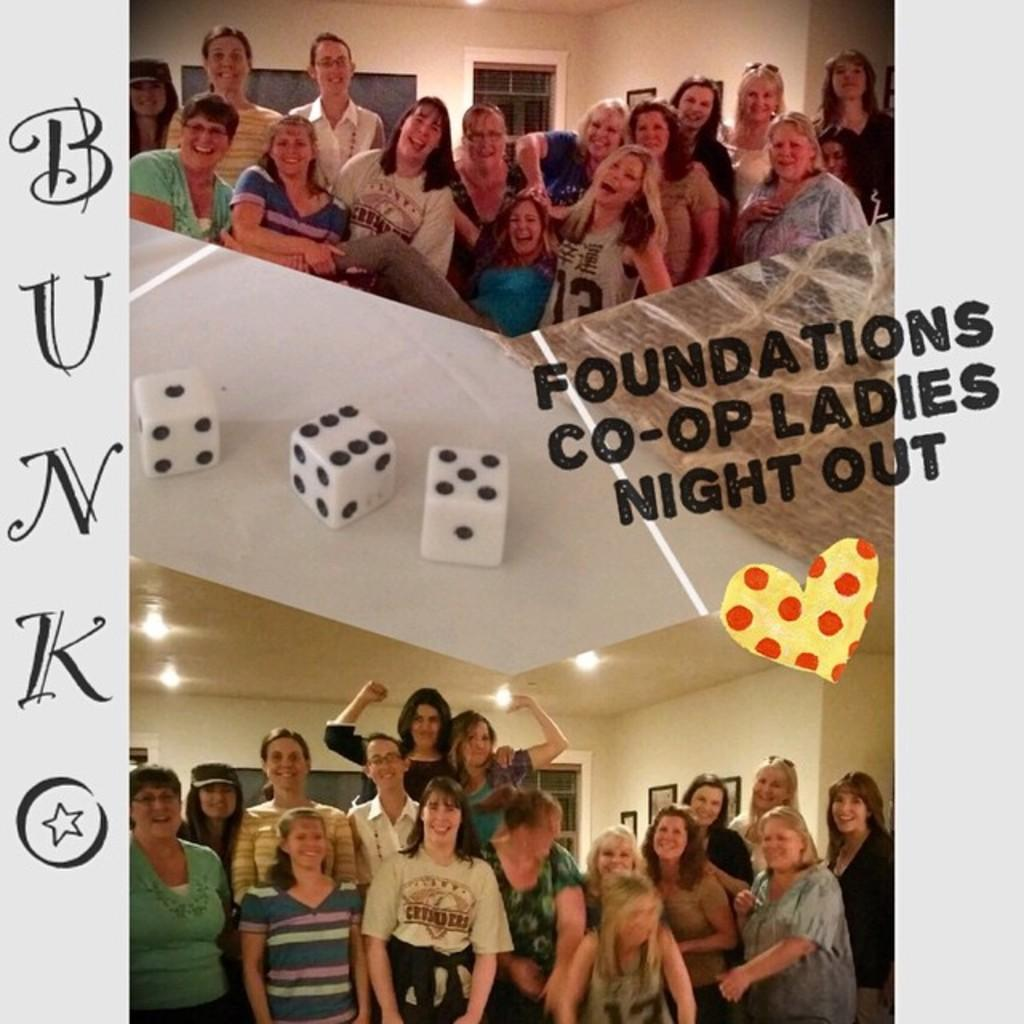What type of picture is the image? The image is a collage picture. What can be seen in the collage picture? There are people in the collage picture. What are the people in the collage picture doing? The people are standing. What expression do the people have in the collage picture? The people are smiling. What type of laborer is depicted in the collage picture? There is no laborer depicted in the collage picture; it features people standing and smiling. What historical event is being commemorated in the collage picture? There is no historical event being commemorated in the collage picture; it is a collage of people standing and smiling. 